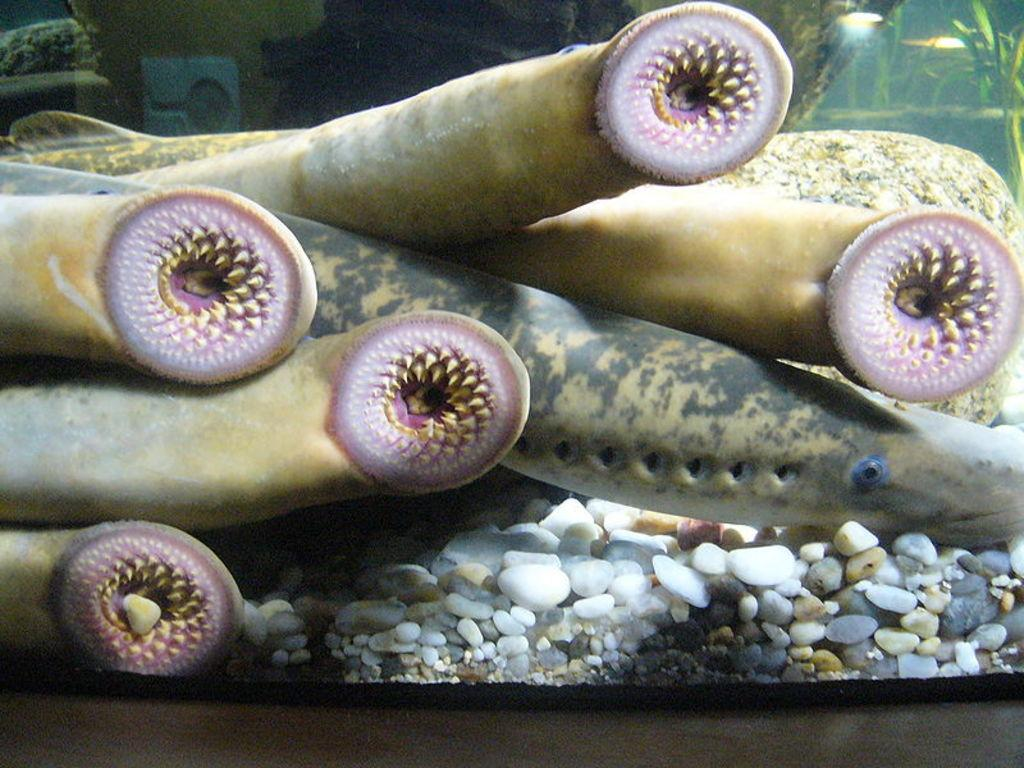What is the main feature of the image? There is an aquarium in the image. What type of animal can be seen in the aquarium? There is a fish in the aquarium. What other creatures are present in the aquarium? There are water animals in the aquarium. What is at the bottom of the aquarium? There are stones at the bottom of the aquarium. What type of boat is visible in the image? There is no boat present in the image; it features an aquarium with fish and water animals. Can you provide a list of all the pets in the image? The image does not contain any pets; it features an aquarium with fish and water animals. 